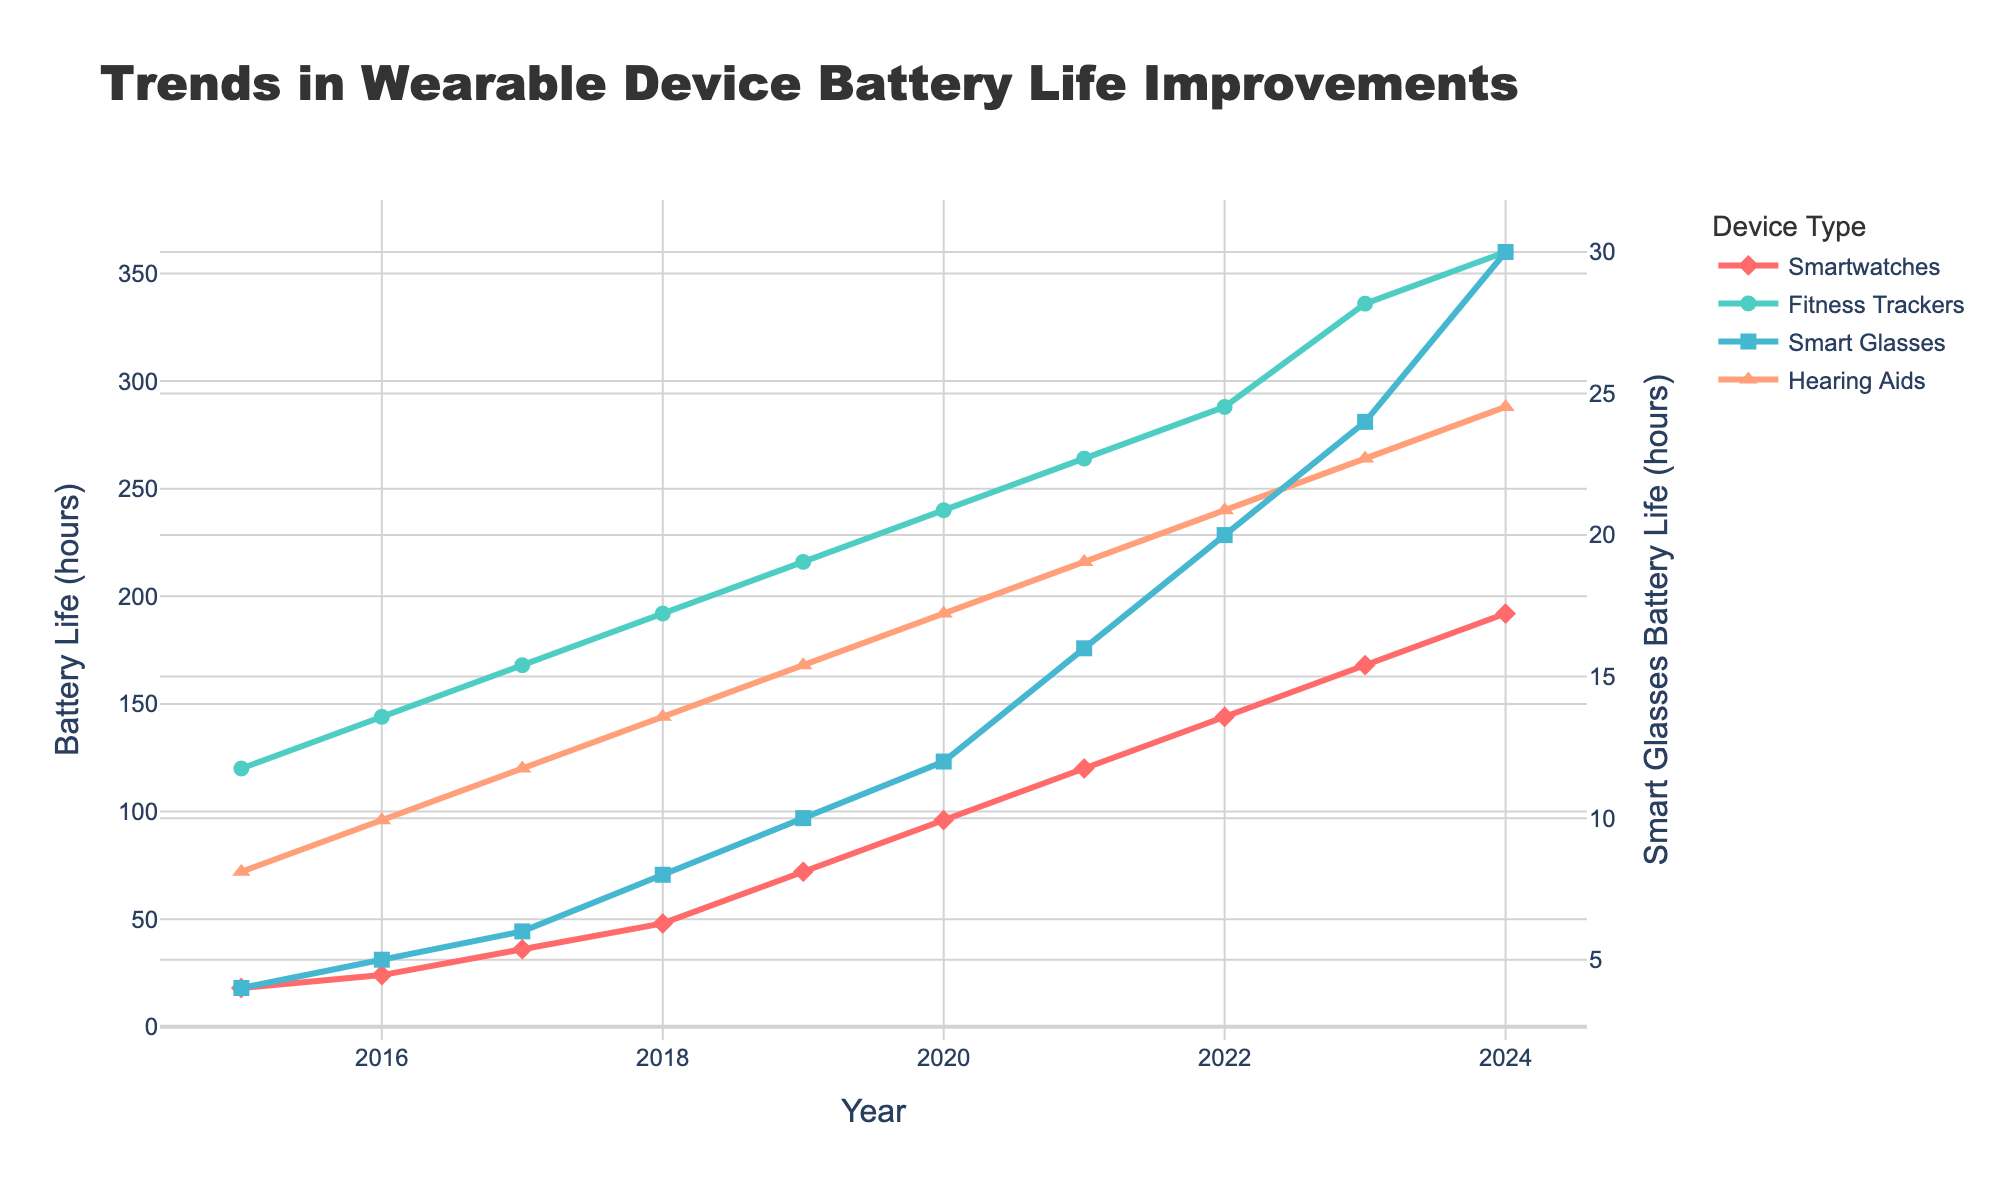What's the battery life improvement for Smartwatches from 2015 to 2024? To find the improvement, subtract the 2015 value from the 2024 value for Smartwatches: 192 - 18 = 174 hours
Answer: 174 hours Which device category had the steepest increase in battery life between 2015 and 2024? Compare the battery life values of all product categories in 2015 and 2024: Smartwatches (192-18=174), Fitness Trackers (360-120=240), Smart Glasses (30-4=26), Hearing Aids (288-72=216). Fitness Trackers had the highest increase
Answer: Fitness Trackers In which year did Hearing Aids have a battery life of 192 hours? By looking at the chart, 192 hours for Hearing Aids is seen in the year 2020
Answer: 2020 How much more battery life did Smart Glasses gain compared to Hearing Aids between 2015 and 2024? Compute battery life gained for both: Smart Glasses (30-4=26), Hearing Aids (288-72=216). Difference = 216 - 26
Answer: 190 hours What is the average battery life of Fitness Trackers between 2015 and 2024? Sum the battery life of Fitness Trackers over the years and divide by the number of years: (120+144+168+192+216+240+264+288+336+360) / 10 = 2400 / 10 = 240
Answer: 240 hours Which product category had the least battery life in 2017? Compare the 2017 values of all product categories: Smartwatches (36), Fitness Trackers (168), Smart Glasses (6), Hearing Aids (120). Smart Glasses had the least
Answer: Smart Glasses How many times higher was the battery life of Fitness Trackers compared to Smartwatches in 2023? Divide the 2023 value of Fitness Trackers by the 2023 value of Smartwatches: 336 / 168 = 2
Answer: 2 times Identify the year when all four product categories saw increments in their battery life. Scan the trend lines and all product categories increased their battery life every year; any year could be picked
Answer: Any year By how many hours did the battery life of Hearing Aids exceed that of Smartwatches in 2024? Subtract the 2024 value of Smartwatches from that of Hearing Aids: 288 - 192 = 96
Answer: 96 hours Which product had its battery life double between 2015 and 2017? Check the values for each product category from 2015 to 2017: Smartwatches (18 to 36), Fitness Trackers (120 to 168), Smart Glasses (4 to 6), Hearing Aids (72 to 120). Only Smartwatches doubled
Answer: Smartwatches 